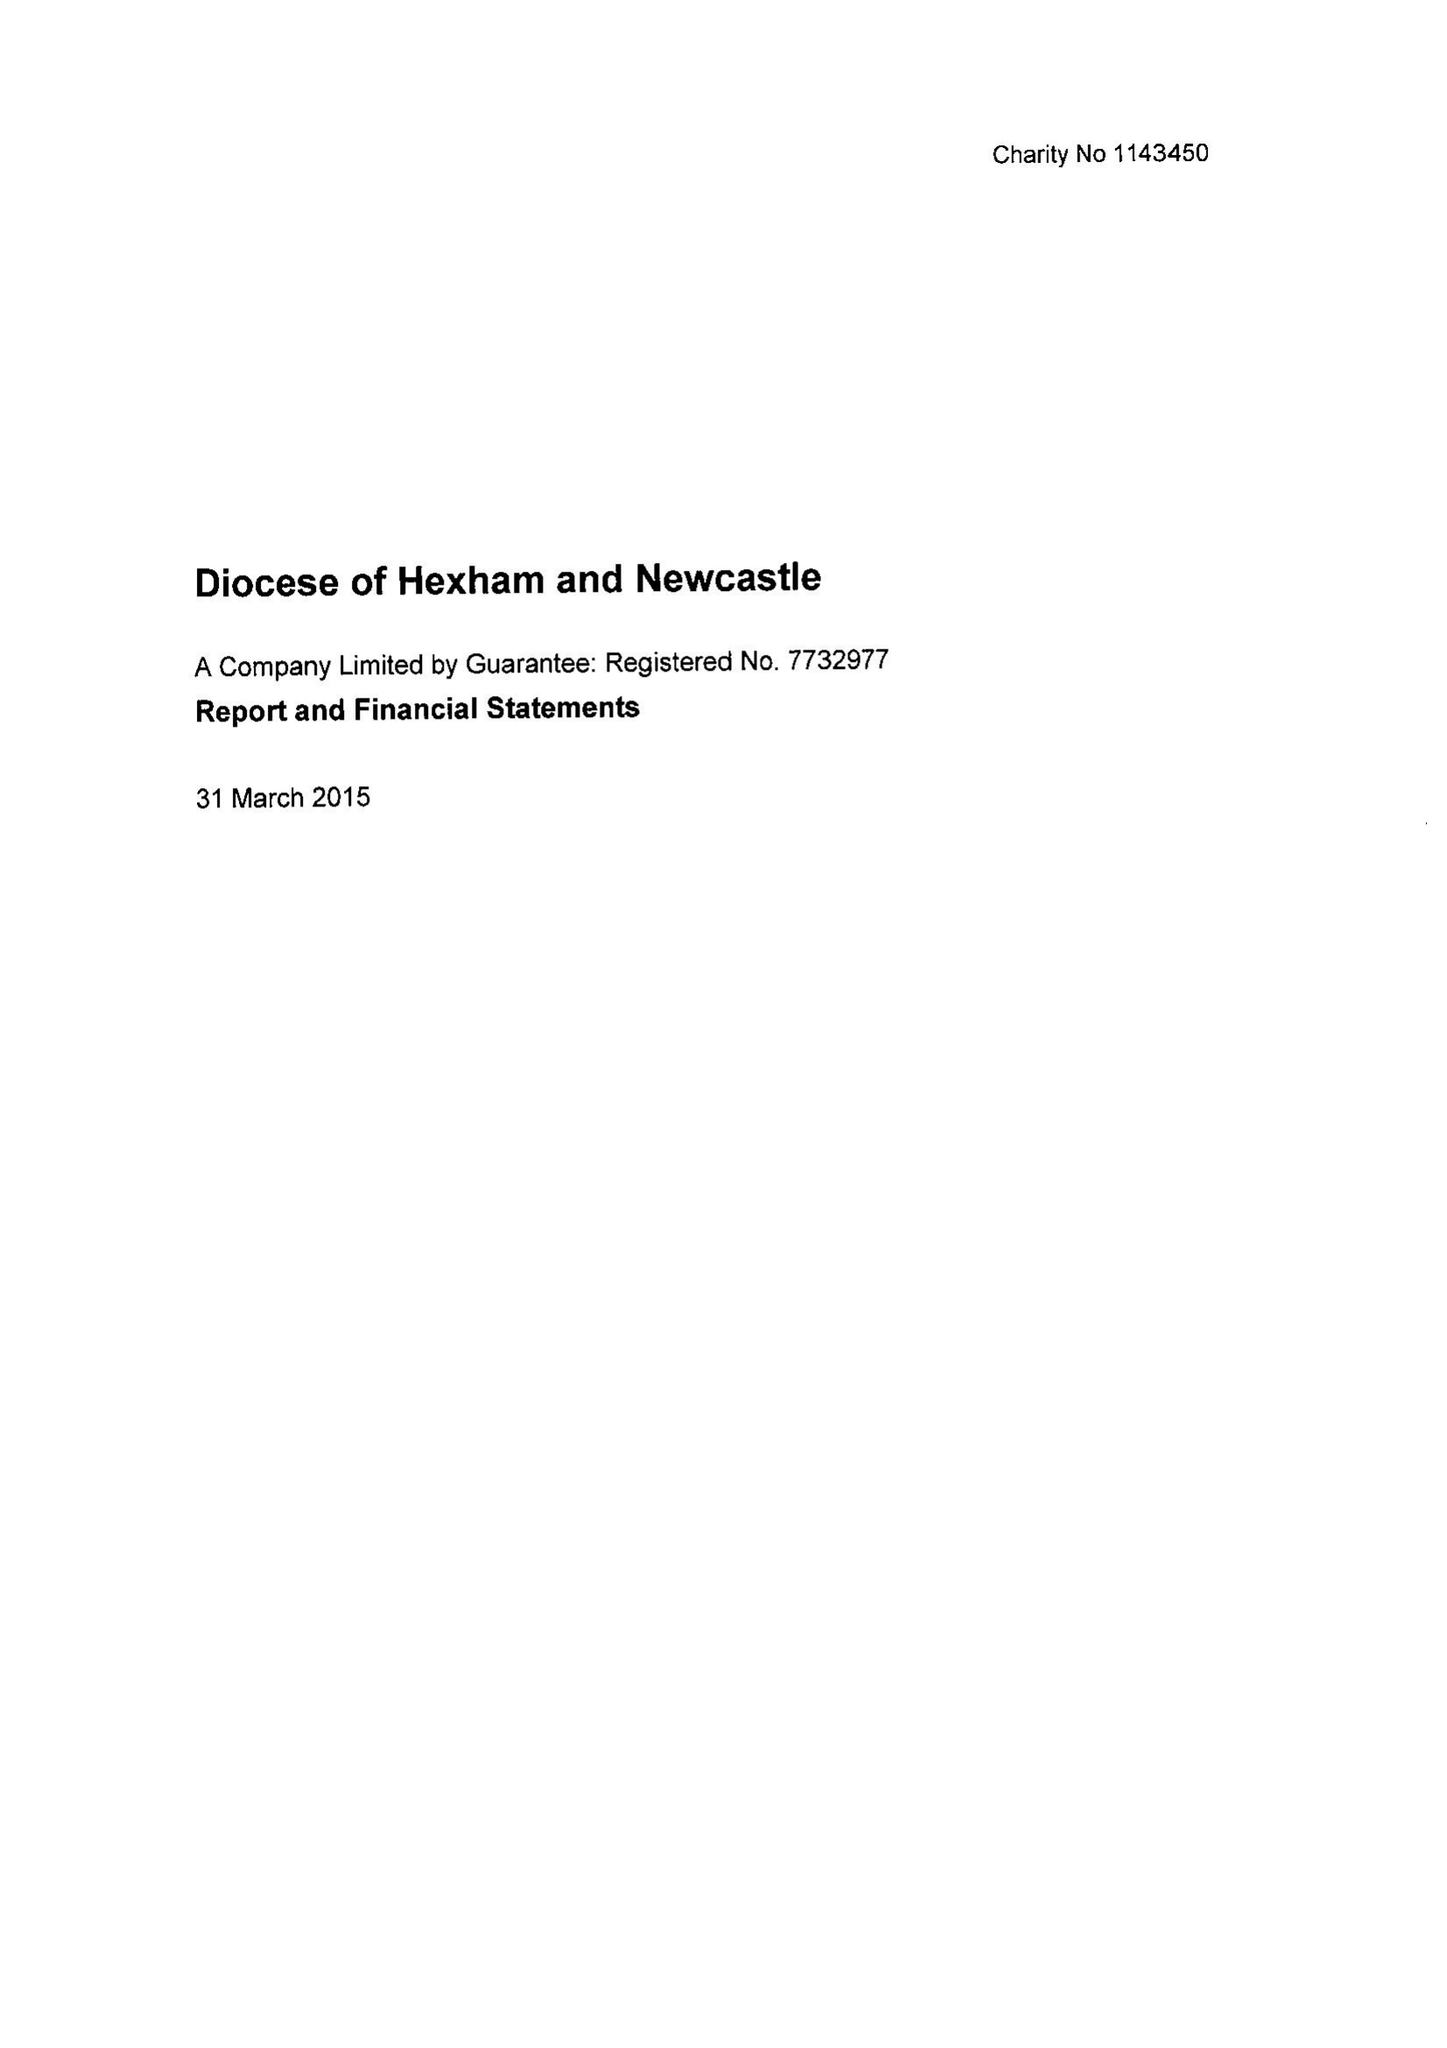What is the value for the report_date?
Answer the question using a single word or phrase. 2015-03-31 